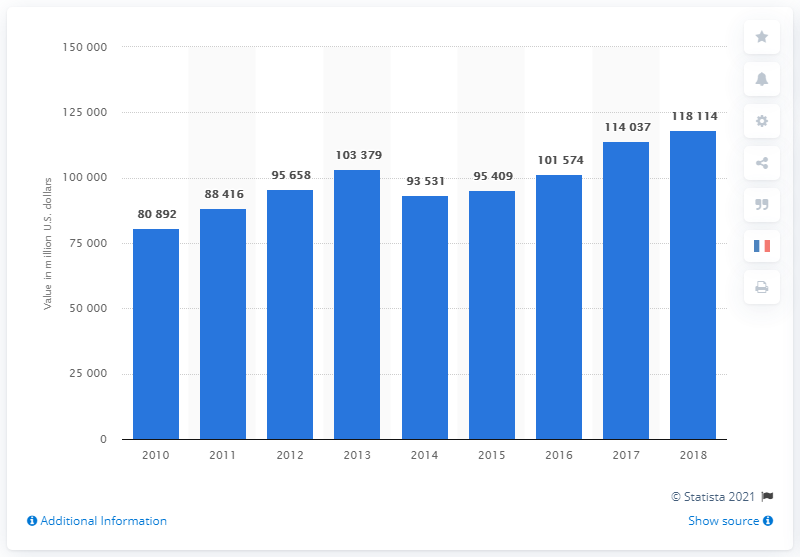Mention a couple of crucial points in this snapshot. In 2016, the equity value of Total was 80,892... 